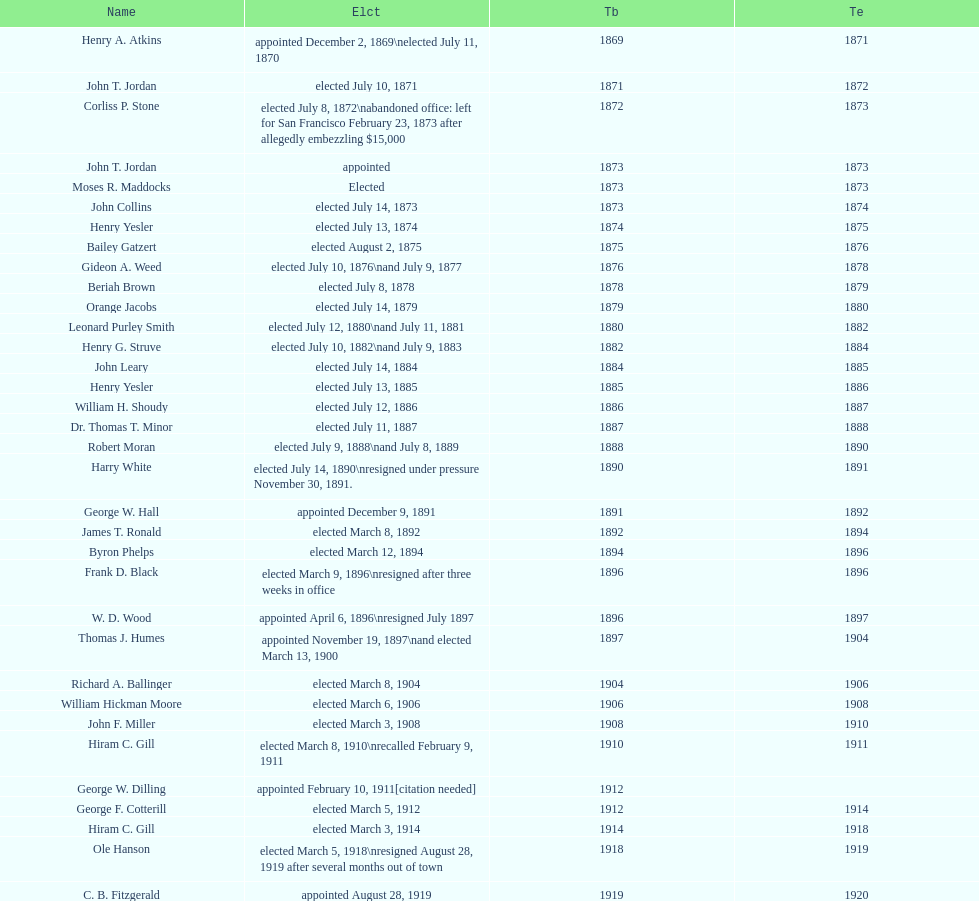How many women have been elected mayor of seattle, washington? 1. 